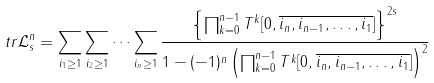<formula> <loc_0><loc_0><loc_500><loc_500>t r \mathcal { L } _ { s } ^ { n } = \sum _ { i _ { 1 } \geq 1 } \sum _ { i _ { 2 } \geq 1 } \dots \sum _ { i _ { n } \geq 1 } \frac { \left \{ \prod _ { k = 0 } ^ { n - 1 } T ^ { k } [ 0 , \overline { i _ { n } , i _ { n - 1 } , \dots , i _ { 1 } } ] \right \} ^ { 2 s } } { 1 - ( - 1 ) ^ { n } \left ( \prod _ { k = 0 } ^ { n - 1 } T ^ { k } [ 0 , \overline { i _ { n } , i _ { n - 1 } , \dots , i _ { 1 } } ] \right ) ^ { 2 } }</formula> 